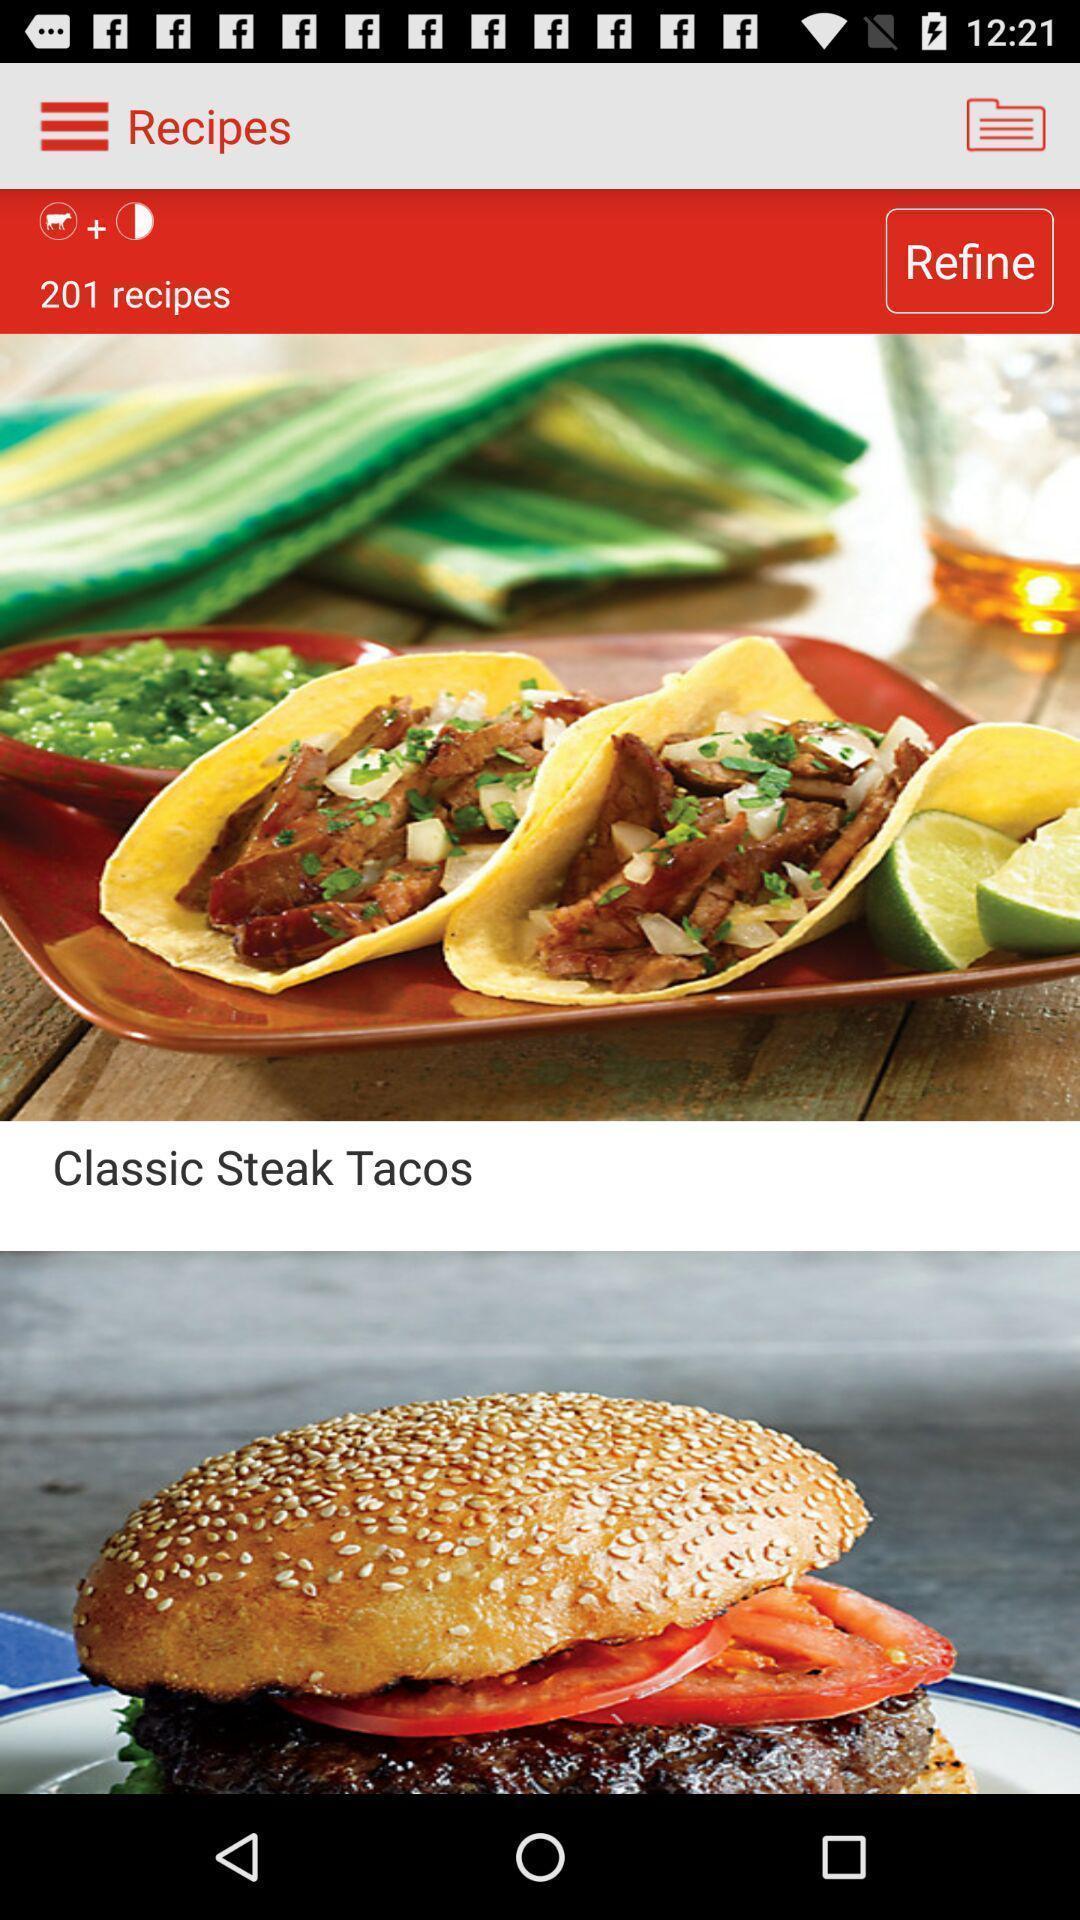Give me a summary of this screen capture. Social app for showing recipes. 